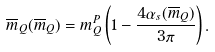Convert formula to latex. <formula><loc_0><loc_0><loc_500><loc_500>\overline { m } _ { Q } ( \overline { m } _ { Q } ) = m ^ { P } _ { Q } \left ( 1 - \frac { 4 \alpha _ { s } ( \overline { m } _ { Q } ) } { 3 \pi } \right ) .</formula> 